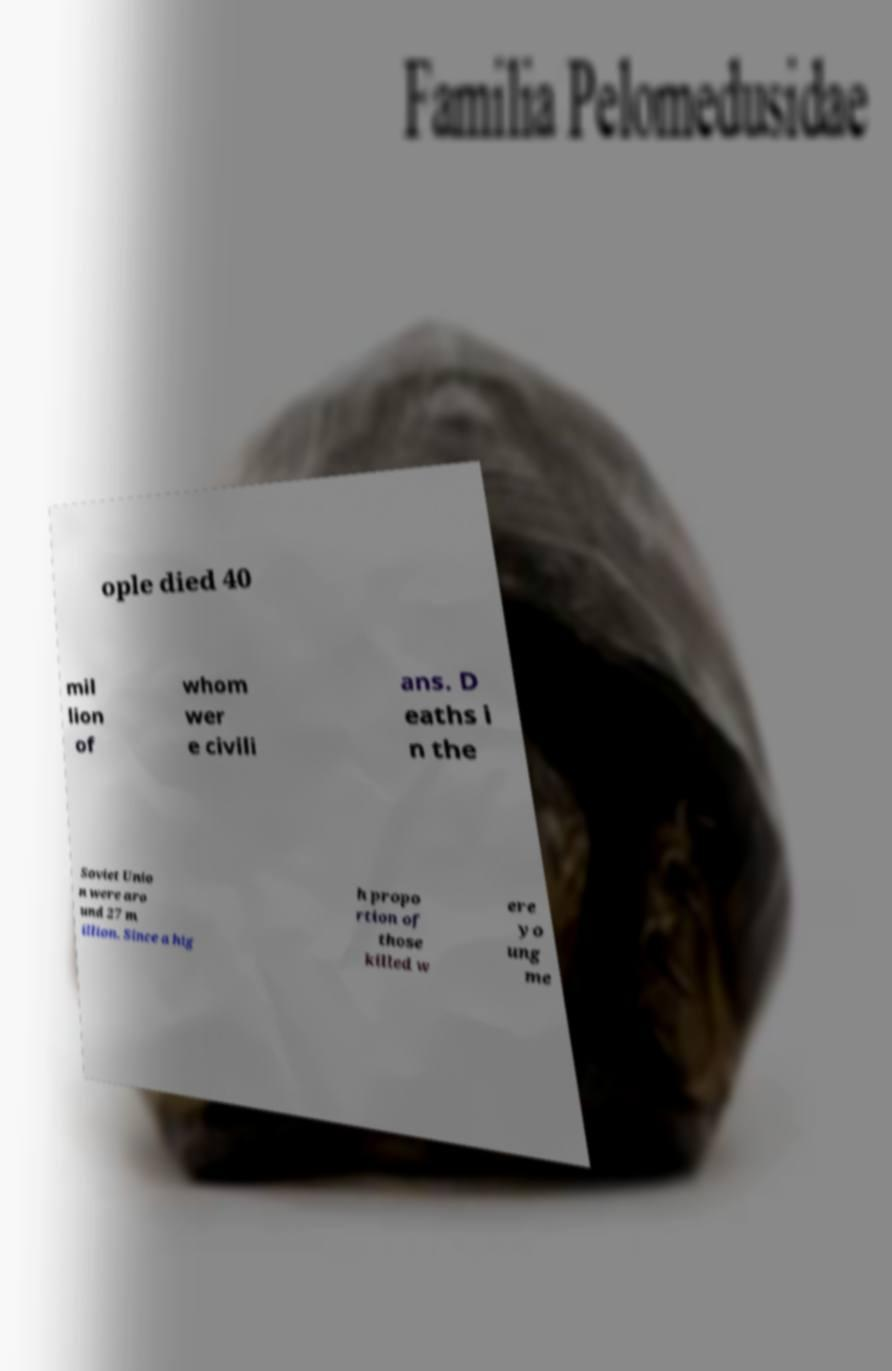There's text embedded in this image that I need extracted. Can you transcribe it verbatim? ople died 40 mil lion of whom wer e civili ans. D eaths i n the Soviet Unio n were aro und 27 m illion. Since a hig h propo rtion of those killed w ere yo ung me 